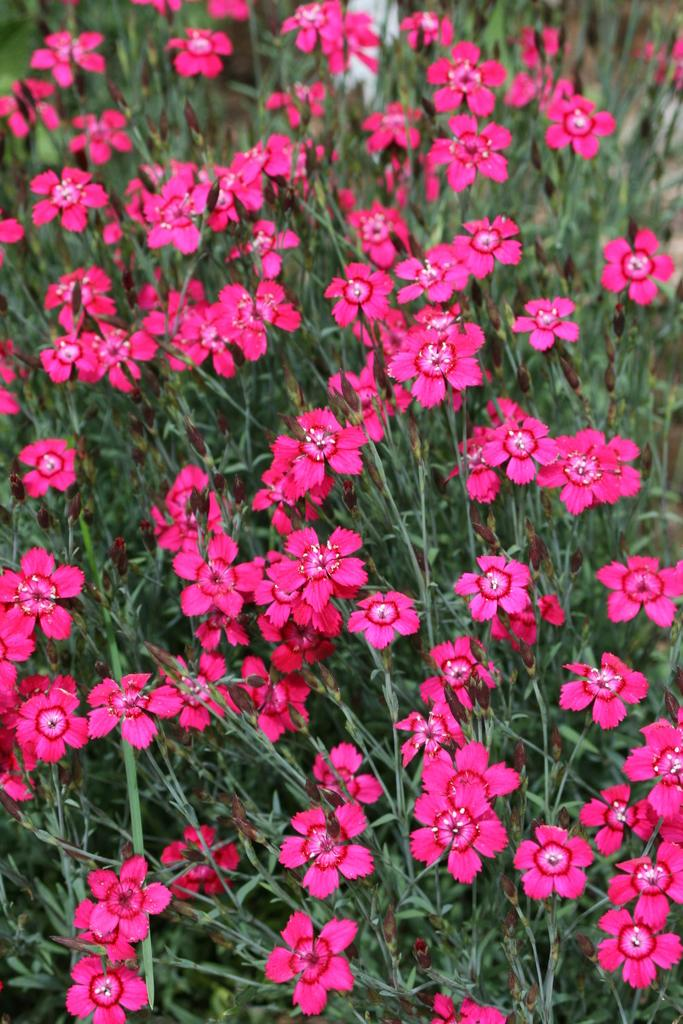What type of living organisms can be seen in the image? Plants and flowers are visible in the image. Can you describe the flowers in the image? The flowers in the image are part of the plants and add color and beauty to the scene. What type of fan can be seen in the image? There is no fan present in the image. What time does the clock show in the image? There is no clock present in the image. 